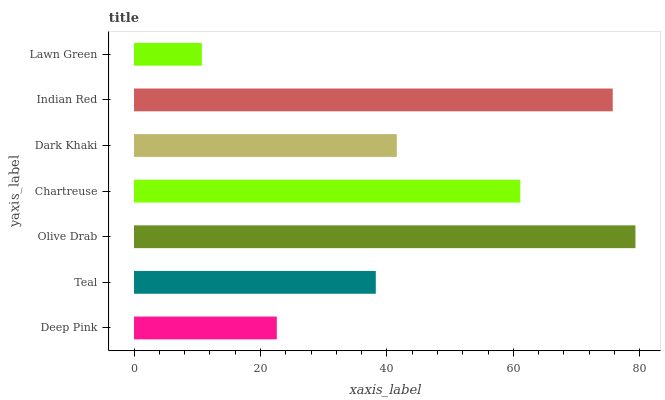Is Lawn Green the minimum?
Answer yes or no. Yes. Is Olive Drab the maximum?
Answer yes or no. Yes. Is Teal the minimum?
Answer yes or no. No. Is Teal the maximum?
Answer yes or no. No. Is Teal greater than Deep Pink?
Answer yes or no. Yes. Is Deep Pink less than Teal?
Answer yes or no. Yes. Is Deep Pink greater than Teal?
Answer yes or no. No. Is Teal less than Deep Pink?
Answer yes or no. No. Is Dark Khaki the high median?
Answer yes or no. Yes. Is Dark Khaki the low median?
Answer yes or no. Yes. Is Lawn Green the high median?
Answer yes or no. No. Is Lawn Green the low median?
Answer yes or no. No. 